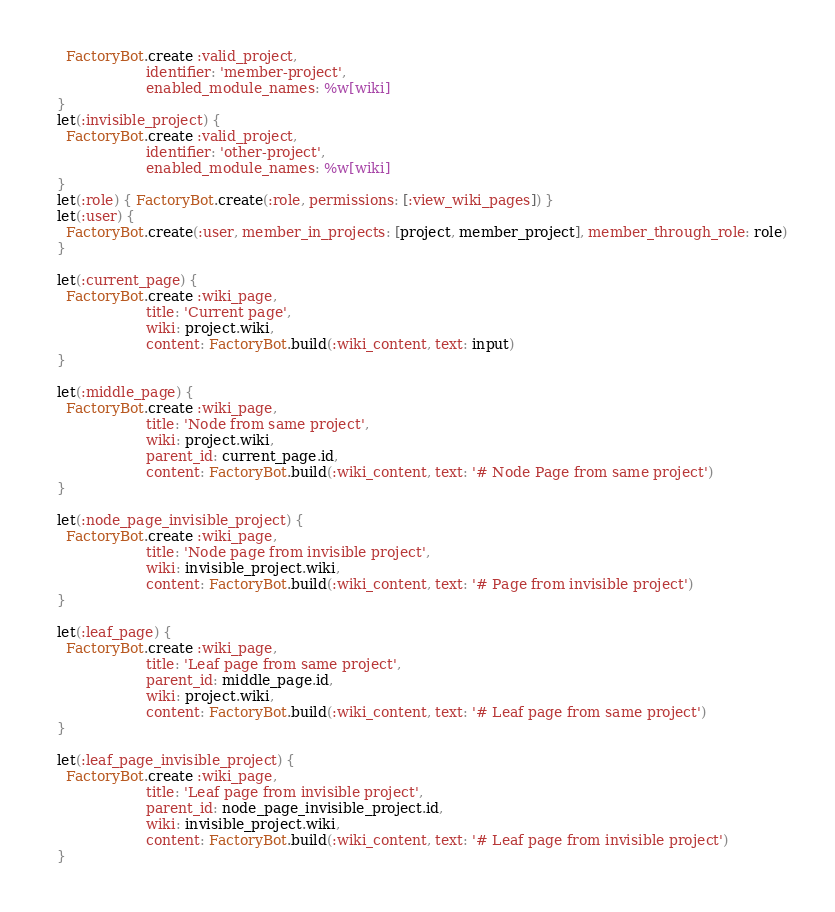Convert code to text. <code><loc_0><loc_0><loc_500><loc_500><_Ruby_>    FactoryBot.create :valid_project,
                      identifier: 'member-project',
                      enabled_module_names: %w[wiki]
  }
  let(:invisible_project) {
    FactoryBot.create :valid_project,
                      identifier: 'other-project',
                      enabled_module_names: %w[wiki]
  }
  let(:role) { FactoryBot.create(:role, permissions: [:view_wiki_pages]) }
  let(:user) {
    FactoryBot.create(:user, member_in_projects: [project, member_project], member_through_role: role)
  }

  let(:current_page) {
    FactoryBot.create :wiki_page,
                      title: 'Current page',
                      wiki: project.wiki,
                      content: FactoryBot.build(:wiki_content, text: input)
  }

  let(:middle_page) {
    FactoryBot.create :wiki_page,
                      title: 'Node from same project',
                      wiki: project.wiki,
                      parent_id: current_page.id,
                      content: FactoryBot.build(:wiki_content, text: '# Node Page from same project')
  }

  let(:node_page_invisible_project) {
    FactoryBot.create :wiki_page,
                      title: 'Node page from invisible project',
                      wiki: invisible_project.wiki,
                      content: FactoryBot.build(:wiki_content, text: '# Page from invisible project')
  }

  let(:leaf_page) {
    FactoryBot.create :wiki_page,
                      title: 'Leaf page from same project',
                      parent_id: middle_page.id,
                      wiki: project.wiki,
                      content: FactoryBot.build(:wiki_content, text: '# Leaf page from same project')
  }

  let(:leaf_page_invisible_project) {
    FactoryBot.create :wiki_page,
                      title: 'Leaf page from invisible project',
                      parent_id: node_page_invisible_project.id,
                      wiki: invisible_project.wiki,
                      content: FactoryBot.build(:wiki_content, text: '# Leaf page from invisible project')
  }
</code> 